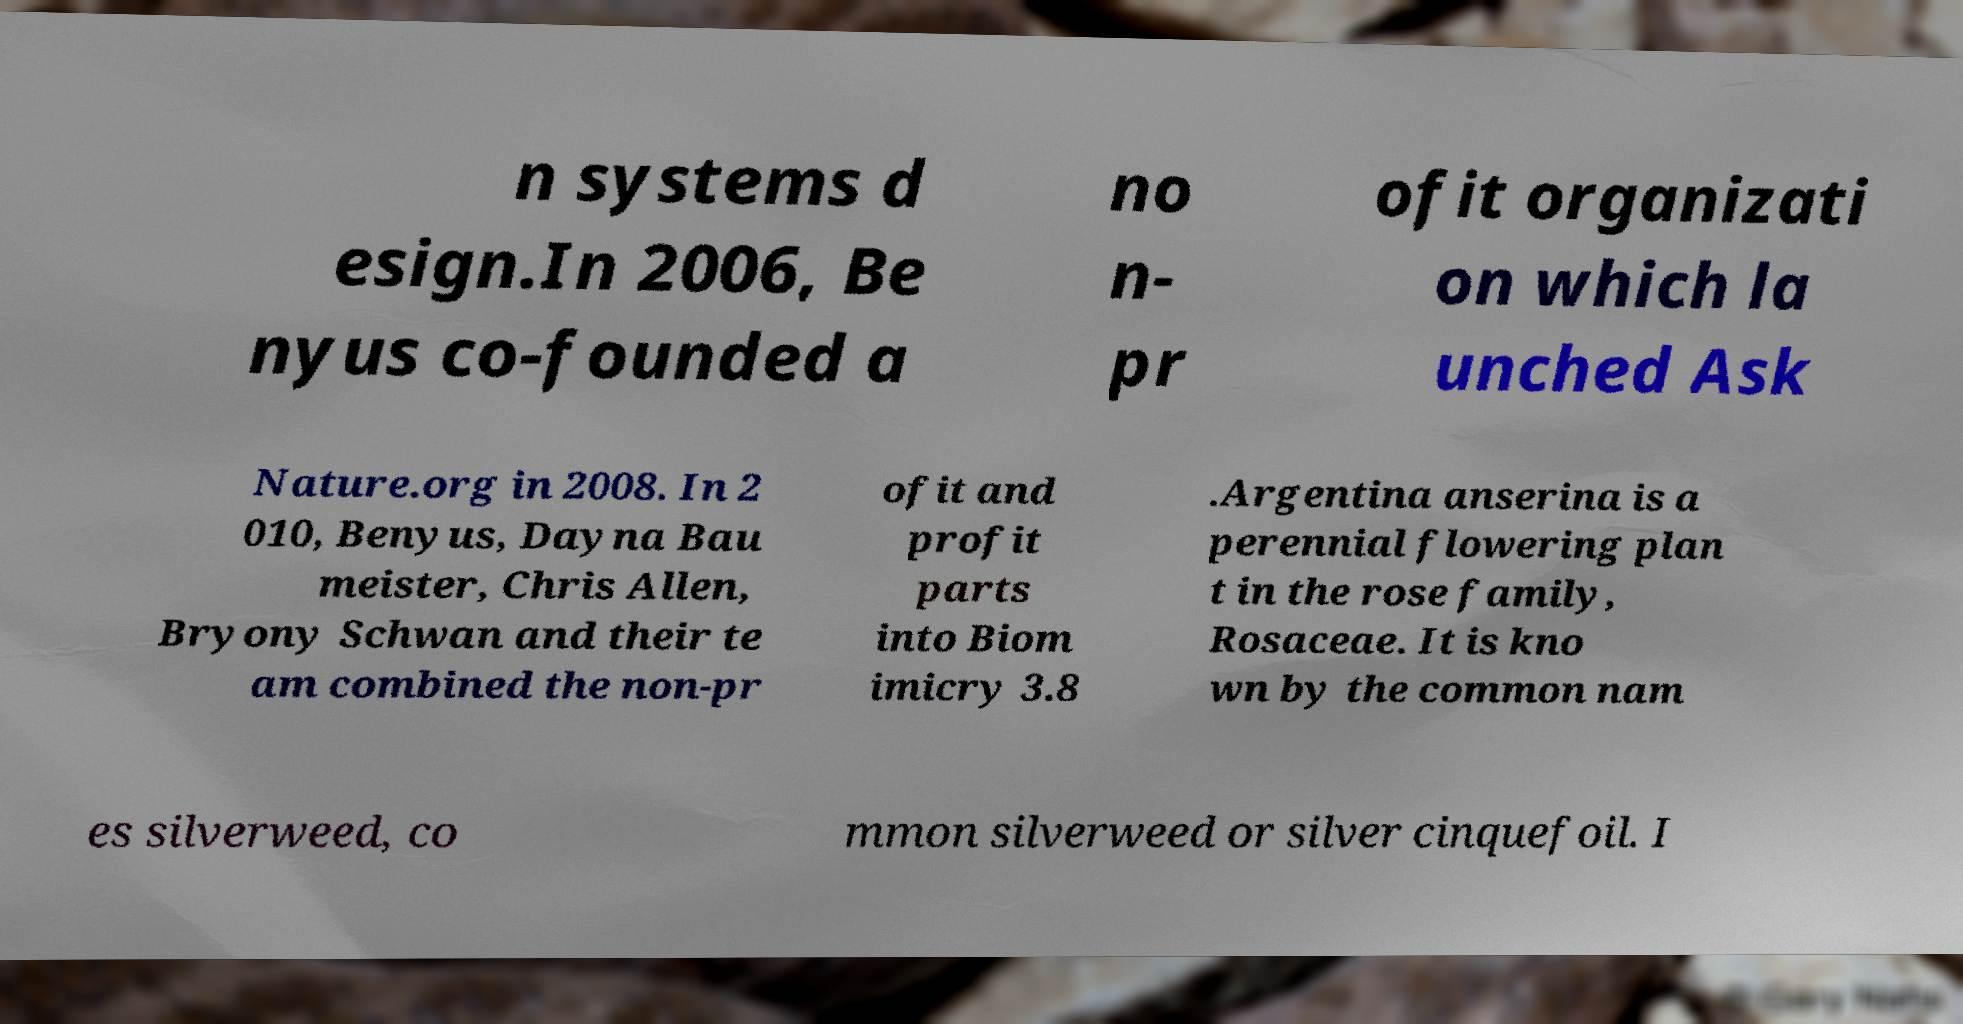Please identify and transcribe the text found in this image. n systems d esign.In 2006, Be nyus co-founded a no n- pr ofit organizati on which la unched Ask Nature.org in 2008. In 2 010, Benyus, Dayna Bau meister, Chris Allen, Bryony Schwan and their te am combined the non-pr ofit and profit parts into Biom imicry 3.8 .Argentina anserina is a perennial flowering plan t in the rose family, Rosaceae. It is kno wn by the common nam es silverweed, co mmon silverweed or silver cinquefoil. I 